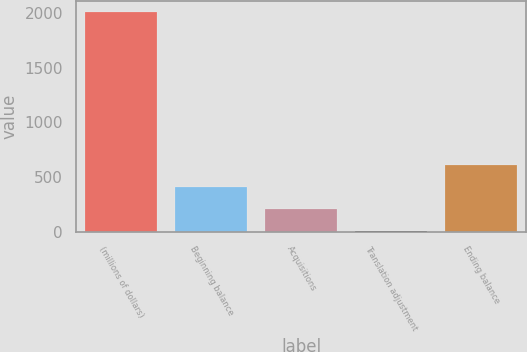Convert chart. <chart><loc_0><loc_0><loc_500><loc_500><bar_chart><fcel>(millions of dollars)<fcel>Beginning balance<fcel>Acquisitions<fcel>Translation adjustment<fcel>Ending balance<nl><fcel>2009<fcel>406.76<fcel>206.48<fcel>6.2<fcel>607.04<nl></chart> 